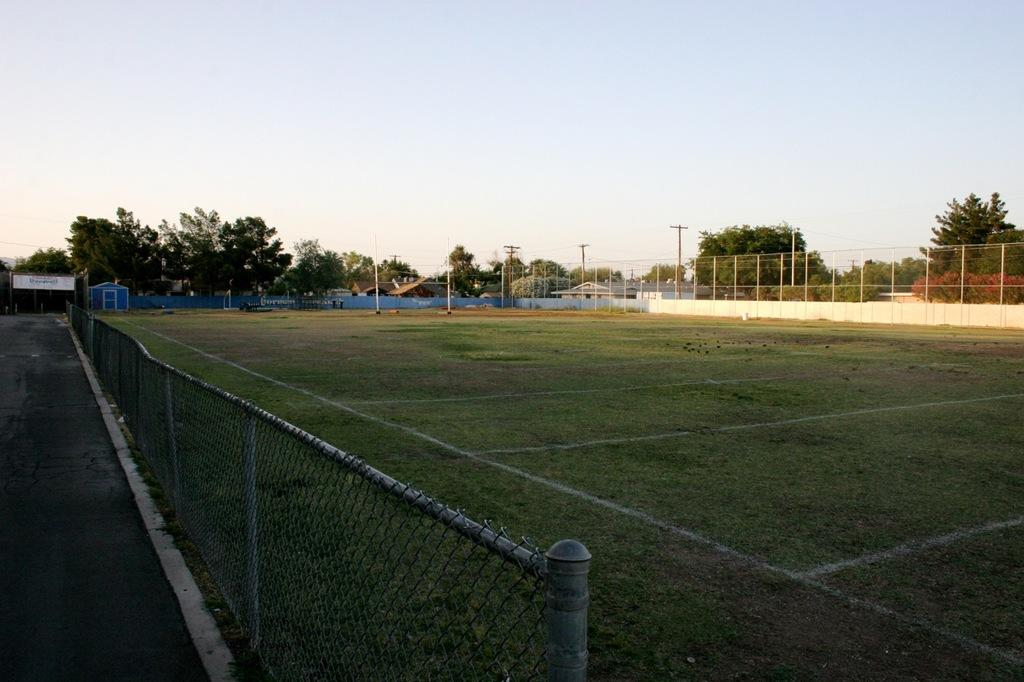What is located at the bottom of the image? There is a fence, grass, and a road at the bottom of the image. What can be seen in the background of the image? There are trees, a fence, electric poles, and the sky visible in the background of the image. What type of science experiment is being conducted with the baby in the image? There is no baby or science experiment present in the image. Can you describe the ray of light shining through the trees in the image? There is no ray of light shining through the trees in the image; only the sky, trees, fence, electric poles, and road are visible. 